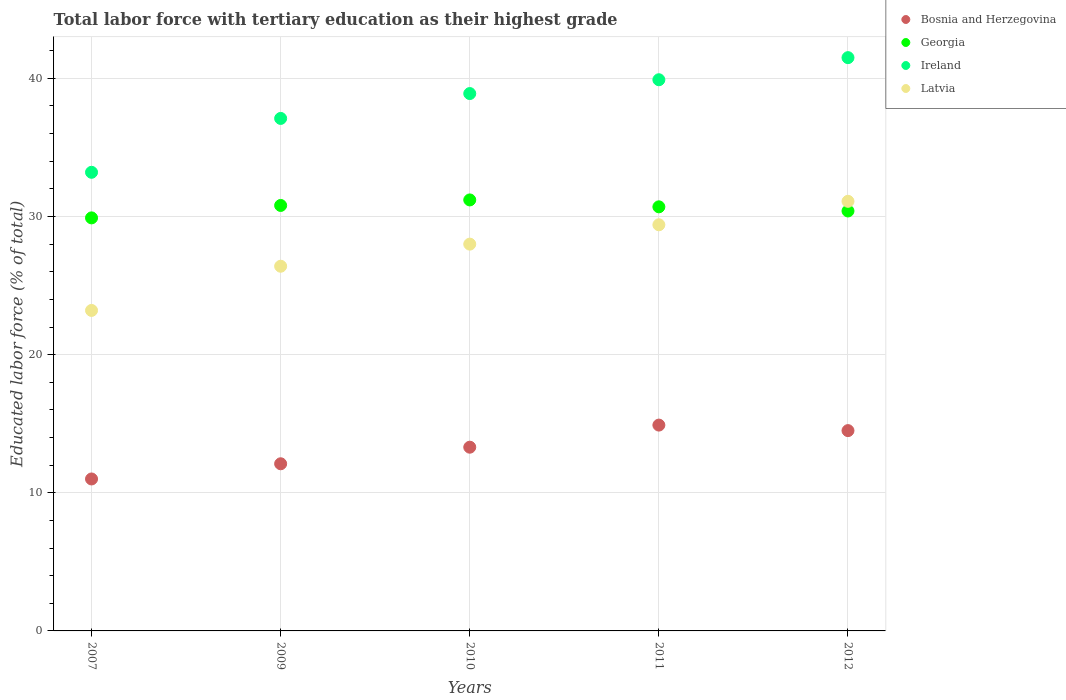How many different coloured dotlines are there?
Ensure brevity in your answer.  4. What is the percentage of male labor force with tertiary education in Ireland in 2011?
Your answer should be very brief. 39.9. Across all years, what is the maximum percentage of male labor force with tertiary education in Georgia?
Give a very brief answer. 31.2. In which year was the percentage of male labor force with tertiary education in Ireland maximum?
Provide a succinct answer. 2012. What is the total percentage of male labor force with tertiary education in Georgia in the graph?
Your answer should be compact. 153. What is the difference between the percentage of male labor force with tertiary education in Bosnia and Herzegovina in 2009 and that in 2010?
Ensure brevity in your answer.  -1.2. What is the difference between the percentage of male labor force with tertiary education in Bosnia and Herzegovina in 2011 and the percentage of male labor force with tertiary education in Georgia in 2010?
Provide a succinct answer. -16.3. What is the average percentage of male labor force with tertiary education in Ireland per year?
Your answer should be compact. 38.12. In the year 2009, what is the difference between the percentage of male labor force with tertiary education in Latvia and percentage of male labor force with tertiary education in Ireland?
Make the answer very short. -10.7. In how many years, is the percentage of male labor force with tertiary education in Ireland greater than 18 %?
Provide a short and direct response. 5. What is the ratio of the percentage of male labor force with tertiary education in Ireland in 2007 to that in 2009?
Provide a short and direct response. 0.89. Is the percentage of male labor force with tertiary education in Georgia in 2007 less than that in 2011?
Your answer should be very brief. Yes. What is the difference between the highest and the second highest percentage of male labor force with tertiary education in Latvia?
Offer a very short reply. 1.7. What is the difference between the highest and the lowest percentage of male labor force with tertiary education in Latvia?
Your answer should be compact. 7.9. In how many years, is the percentage of male labor force with tertiary education in Bosnia and Herzegovina greater than the average percentage of male labor force with tertiary education in Bosnia and Herzegovina taken over all years?
Offer a very short reply. 3. Is the sum of the percentage of male labor force with tertiary education in Latvia in 2009 and 2010 greater than the maximum percentage of male labor force with tertiary education in Bosnia and Herzegovina across all years?
Offer a very short reply. Yes. Is it the case that in every year, the sum of the percentage of male labor force with tertiary education in Ireland and percentage of male labor force with tertiary education in Latvia  is greater than the sum of percentage of male labor force with tertiary education in Georgia and percentage of male labor force with tertiary education in Bosnia and Herzegovina?
Provide a succinct answer. No. Is it the case that in every year, the sum of the percentage of male labor force with tertiary education in Ireland and percentage of male labor force with tertiary education in Latvia  is greater than the percentage of male labor force with tertiary education in Bosnia and Herzegovina?
Provide a succinct answer. Yes. How many years are there in the graph?
Your answer should be compact. 5. What is the difference between two consecutive major ticks on the Y-axis?
Offer a very short reply. 10. Are the values on the major ticks of Y-axis written in scientific E-notation?
Ensure brevity in your answer.  No. Does the graph contain grids?
Your answer should be compact. Yes. How many legend labels are there?
Your response must be concise. 4. How are the legend labels stacked?
Offer a terse response. Vertical. What is the title of the graph?
Provide a short and direct response. Total labor force with tertiary education as their highest grade. Does "St. Vincent and the Grenadines" appear as one of the legend labels in the graph?
Ensure brevity in your answer.  No. What is the label or title of the Y-axis?
Provide a short and direct response. Educated labor force (% of total). What is the Educated labor force (% of total) of Bosnia and Herzegovina in 2007?
Provide a succinct answer. 11. What is the Educated labor force (% of total) of Georgia in 2007?
Provide a succinct answer. 29.9. What is the Educated labor force (% of total) of Ireland in 2007?
Provide a succinct answer. 33.2. What is the Educated labor force (% of total) in Latvia in 2007?
Ensure brevity in your answer.  23.2. What is the Educated labor force (% of total) of Bosnia and Herzegovina in 2009?
Give a very brief answer. 12.1. What is the Educated labor force (% of total) of Georgia in 2009?
Offer a very short reply. 30.8. What is the Educated labor force (% of total) in Ireland in 2009?
Give a very brief answer. 37.1. What is the Educated labor force (% of total) of Latvia in 2009?
Ensure brevity in your answer.  26.4. What is the Educated labor force (% of total) of Bosnia and Herzegovina in 2010?
Offer a terse response. 13.3. What is the Educated labor force (% of total) of Georgia in 2010?
Provide a succinct answer. 31.2. What is the Educated labor force (% of total) in Ireland in 2010?
Provide a short and direct response. 38.9. What is the Educated labor force (% of total) of Bosnia and Herzegovina in 2011?
Give a very brief answer. 14.9. What is the Educated labor force (% of total) in Georgia in 2011?
Your answer should be compact. 30.7. What is the Educated labor force (% of total) of Ireland in 2011?
Ensure brevity in your answer.  39.9. What is the Educated labor force (% of total) in Latvia in 2011?
Provide a short and direct response. 29.4. What is the Educated labor force (% of total) of Bosnia and Herzegovina in 2012?
Offer a terse response. 14.5. What is the Educated labor force (% of total) in Georgia in 2012?
Make the answer very short. 30.4. What is the Educated labor force (% of total) of Ireland in 2012?
Provide a succinct answer. 41.5. What is the Educated labor force (% of total) of Latvia in 2012?
Your answer should be compact. 31.1. Across all years, what is the maximum Educated labor force (% of total) of Bosnia and Herzegovina?
Make the answer very short. 14.9. Across all years, what is the maximum Educated labor force (% of total) in Georgia?
Provide a succinct answer. 31.2. Across all years, what is the maximum Educated labor force (% of total) of Ireland?
Provide a short and direct response. 41.5. Across all years, what is the maximum Educated labor force (% of total) in Latvia?
Offer a terse response. 31.1. Across all years, what is the minimum Educated labor force (% of total) of Georgia?
Give a very brief answer. 29.9. Across all years, what is the minimum Educated labor force (% of total) of Ireland?
Your response must be concise. 33.2. Across all years, what is the minimum Educated labor force (% of total) in Latvia?
Provide a short and direct response. 23.2. What is the total Educated labor force (% of total) in Bosnia and Herzegovina in the graph?
Your answer should be very brief. 65.8. What is the total Educated labor force (% of total) of Georgia in the graph?
Keep it short and to the point. 153. What is the total Educated labor force (% of total) in Ireland in the graph?
Provide a succinct answer. 190.6. What is the total Educated labor force (% of total) in Latvia in the graph?
Ensure brevity in your answer.  138.1. What is the difference between the Educated labor force (% of total) in Bosnia and Herzegovina in 2007 and that in 2009?
Provide a succinct answer. -1.1. What is the difference between the Educated labor force (% of total) in Ireland in 2007 and that in 2009?
Offer a terse response. -3.9. What is the difference between the Educated labor force (% of total) of Latvia in 2007 and that in 2009?
Your response must be concise. -3.2. What is the difference between the Educated labor force (% of total) in Bosnia and Herzegovina in 2007 and that in 2010?
Your answer should be compact. -2.3. What is the difference between the Educated labor force (% of total) of Ireland in 2007 and that in 2010?
Provide a succinct answer. -5.7. What is the difference between the Educated labor force (% of total) in Latvia in 2007 and that in 2010?
Offer a terse response. -4.8. What is the difference between the Educated labor force (% of total) in Ireland in 2007 and that in 2011?
Offer a very short reply. -6.7. What is the difference between the Educated labor force (% of total) of Bosnia and Herzegovina in 2007 and that in 2012?
Your answer should be very brief. -3.5. What is the difference between the Educated labor force (% of total) in Georgia in 2007 and that in 2012?
Your response must be concise. -0.5. What is the difference between the Educated labor force (% of total) in Ireland in 2007 and that in 2012?
Offer a terse response. -8.3. What is the difference between the Educated labor force (% of total) in Latvia in 2007 and that in 2012?
Provide a short and direct response. -7.9. What is the difference between the Educated labor force (% of total) of Georgia in 2009 and that in 2010?
Provide a succinct answer. -0.4. What is the difference between the Educated labor force (% of total) in Georgia in 2009 and that in 2011?
Your answer should be compact. 0.1. What is the difference between the Educated labor force (% of total) of Bosnia and Herzegovina in 2009 and that in 2012?
Provide a short and direct response. -2.4. What is the difference between the Educated labor force (% of total) of Ireland in 2009 and that in 2012?
Your response must be concise. -4.4. What is the difference between the Educated labor force (% of total) of Latvia in 2009 and that in 2012?
Provide a short and direct response. -4.7. What is the difference between the Educated labor force (% of total) of Georgia in 2010 and that in 2011?
Provide a succinct answer. 0.5. What is the difference between the Educated labor force (% of total) of Ireland in 2010 and that in 2011?
Your answer should be compact. -1. What is the difference between the Educated labor force (% of total) of Bosnia and Herzegovina in 2010 and that in 2012?
Offer a very short reply. -1.2. What is the difference between the Educated labor force (% of total) of Latvia in 2010 and that in 2012?
Make the answer very short. -3.1. What is the difference between the Educated labor force (% of total) in Bosnia and Herzegovina in 2011 and that in 2012?
Provide a succinct answer. 0.4. What is the difference between the Educated labor force (% of total) of Ireland in 2011 and that in 2012?
Offer a very short reply. -1.6. What is the difference between the Educated labor force (% of total) of Bosnia and Herzegovina in 2007 and the Educated labor force (% of total) of Georgia in 2009?
Offer a terse response. -19.8. What is the difference between the Educated labor force (% of total) of Bosnia and Herzegovina in 2007 and the Educated labor force (% of total) of Ireland in 2009?
Offer a terse response. -26.1. What is the difference between the Educated labor force (% of total) in Bosnia and Herzegovina in 2007 and the Educated labor force (% of total) in Latvia in 2009?
Your response must be concise. -15.4. What is the difference between the Educated labor force (% of total) in Georgia in 2007 and the Educated labor force (% of total) in Ireland in 2009?
Your response must be concise. -7.2. What is the difference between the Educated labor force (% of total) of Georgia in 2007 and the Educated labor force (% of total) of Latvia in 2009?
Offer a very short reply. 3.5. What is the difference between the Educated labor force (% of total) of Ireland in 2007 and the Educated labor force (% of total) of Latvia in 2009?
Offer a terse response. 6.8. What is the difference between the Educated labor force (% of total) of Bosnia and Herzegovina in 2007 and the Educated labor force (% of total) of Georgia in 2010?
Provide a short and direct response. -20.2. What is the difference between the Educated labor force (% of total) of Bosnia and Herzegovina in 2007 and the Educated labor force (% of total) of Ireland in 2010?
Your response must be concise. -27.9. What is the difference between the Educated labor force (% of total) in Bosnia and Herzegovina in 2007 and the Educated labor force (% of total) in Latvia in 2010?
Your response must be concise. -17. What is the difference between the Educated labor force (% of total) of Ireland in 2007 and the Educated labor force (% of total) of Latvia in 2010?
Your response must be concise. 5.2. What is the difference between the Educated labor force (% of total) of Bosnia and Herzegovina in 2007 and the Educated labor force (% of total) of Georgia in 2011?
Ensure brevity in your answer.  -19.7. What is the difference between the Educated labor force (% of total) of Bosnia and Herzegovina in 2007 and the Educated labor force (% of total) of Ireland in 2011?
Ensure brevity in your answer.  -28.9. What is the difference between the Educated labor force (% of total) of Bosnia and Herzegovina in 2007 and the Educated labor force (% of total) of Latvia in 2011?
Your response must be concise. -18.4. What is the difference between the Educated labor force (% of total) of Georgia in 2007 and the Educated labor force (% of total) of Latvia in 2011?
Provide a succinct answer. 0.5. What is the difference between the Educated labor force (% of total) of Bosnia and Herzegovina in 2007 and the Educated labor force (% of total) of Georgia in 2012?
Ensure brevity in your answer.  -19.4. What is the difference between the Educated labor force (% of total) of Bosnia and Herzegovina in 2007 and the Educated labor force (% of total) of Ireland in 2012?
Offer a terse response. -30.5. What is the difference between the Educated labor force (% of total) of Bosnia and Herzegovina in 2007 and the Educated labor force (% of total) of Latvia in 2012?
Your answer should be very brief. -20.1. What is the difference between the Educated labor force (% of total) of Bosnia and Herzegovina in 2009 and the Educated labor force (% of total) of Georgia in 2010?
Offer a terse response. -19.1. What is the difference between the Educated labor force (% of total) of Bosnia and Herzegovina in 2009 and the Educated labor force (% of total) of Ireland in 2010?
Provide a succinct answer. -26.8. What is the difference between the Educated labor force (% of total) of Bosnia and Herzegovina in 2009 and the Educated labor force (% of total) of Latvia in 2010?
Provide a short and direct response. -15.9. What is the difference between the Educated labor force (% of total) in Bosnia and Herzegovina in 2009 and the Educated labor force (% of total) in Georgia in 2011?
Provide a succinct answer. -18.6. What is the difference between the Educated labor force (% of total) of Bosnia and Herzegovina in 2009 and the Educated labor force (% of total) of Ireland in 2011?
Your answer should be very brief. -27.8. What is the difference between the Educated labor force (% of total) of Bosnia and Herzegovina in 2009 and the Educated labor force (% of total) of Latvia in 2011?
Provide a short and direct response. -17.3. What is the difference between the Educated labor force (% of total) of Georgia in 2009 and the Educated labor force (% of total) of Latvia in 2011?
Offer a very short reply. 1.4. What is the difference between the Educated labor force (% of total) of Ireland in 2009 and the Educated labor force (% of total) of Latvia in 2011?
Ensure brevity in your answer.  7.7. What is the difference between the Educated labor force (% of total) in Bosnia and Herzegovina in 2009 and the Educated labor force (% of total) in Georgia in 2012?
Offer a terse response. -18.3. What is the difference between the Educated labor force (% of total) in Bosnia and Herzegovina in 2009 and the Educated labor force (% of total) in Ireland in 2012?
Provide a succinct answer. -29.4. What is the difference between the Educated labor force (% of total) of Bosnia and Herzegovina in 2009 and the Educated labor force (% of total) of Latvia in 2012?
Provide a short and direct response. -19. What is the difference between the Educated labor force (% of total) in Georgia in 2009 and the Educated labor force (% of total) in Ireland in 2012?
Offer a terse response. -10.7. What is the difference between the Educated labor force (% of total) of Georgia in 2009 and the Educated labor force (% of total) of Latvia in 2012?
Your response must be concise. -0.3. What is the difference between the Educated labor force (% of total) of Ireland in 2009 and the Educated labor force (% of total) of Latvia in 2012?
Provide a short and direct response. 6. What is the difference between the Educated labor force (% of total) of Bosnia and Herzegovina in 2010 and the Educated labor force (% of total) of Georgia in 2011?
Your response must be concise. -17.4. What is the difference between the Educated labor force (% of total) in Bosnia and Herzegovina in 2010 and the Educated labor force (% of total) in Ireland in 2011?
Ensure brevity in your answer.  -26.6. What is the difference between the Educated labor force (% of total) of Bosnia and Herzegovina in 2010 and the Educated labor force (% of total) of Latvia in 2011?
Offer a very short reply. -16.1. What is the difference between the Educated labor force (% of total) in Georgia in 2010 and the Educated labor force (% of total) in Ireland in 2011?
Your answer should be compact. -8.7. What is the difference between the Educated labor force (% of total) in Georgia in 2010 and the Educated labor force (% of total) in Latvia in 2011?
Provide a succinct answer. 1.8. What is the difference between the Educated labor force (% of total) of Ireland in 2010 and the Educated labor force (% of total) of Latvia in 2011?
Offer a terse response. 9.5. What is the difference between the Educated labor force (% of total) in Bosnia and Herzegovina in 2010 and the Educated labor force (% of total) in Georgia in 2012?
Offer a very short reply. -17.1. What is the difference between the Educated labor force (% of total) in Bosnia and Herzegovina in 2010 and the Educated labor force (% of total) in Ireland in 2012?
Keep it short and to the point. -28.2. What is the difference between the Educated labor force (% of total) of Bosnia and Herzegovina in 2010 and the Educated labor force (% of total) of Latvia in 2012?
Your response must be concise. -17.8. What is the difference between the Educated labor force (% of total) of Georgia in 2010 and the Educated labor force (% of total) of Latvia in 2012?
Provide a short and direct response. 0.1. What is the difference between the Educated labor force (% of total) in Ireland in 2010 and the Educated labor force (% of total) in Latvia in 2012?
Provide a succinct answer. 7.8. What is the difference between the Educated labor force (% of total) in Bosnia and Herzegovina in 2011 and the Educated labor force (% of total) in Georgia in 2012?
Your answer should be very brief. -15.5. What is the difference between the Educated labor force (% of total) of Bosnia and Herzegovina in 2011 and the Educated labor force (% of total) of Ireland in 2012?
Your answer should be very brief. -26.6. What is the difference between the Educated labor force (% of total) of Bosnia and Herzegovina in 2011 and the Educated labor force (% of total) of Latvia in 2012?
Your answer should be compact. -16.2. What is the difference between the Educated labor force (% of total) of Georgia in 2011 and the Educated labor force (% of total) of Ireland in 2012?
Make the answer very short. -10.8. What is the difference between the Educated labor force (% of total) of Ireland in 2011 and the Educated labor force (% of total) of Latvia in 2012?
Your answer should be compact. 8.8. What is the average Educated labor force (% of total) of Bosnia and Herzegovina per year?
Your answer should be very brief. 13.16. What is the average Educated labor force (% of total) of Georgia per year?
Ensure brevity in your answer.  30.6. What is the average Educated labor force (% of total) of Ireland per year?
Provide a short and direct response. 38.12. What is the average Educated labor force (% of total) of Latvia per year?
Offer a very short reply. 27.62. In the year 2007, what is the difference between the Educated labor force (% of total) in Bosnia and Herzegovina and Educated labor force (% of total) in Georgia?
Offer a very short reply. -18.9. In the year 2007, what is the difference between the Educated labor force (% of total) in Bosnia and Herzegovina and Educated labor force (% of total) in Ireland?
Offer a terse response. -22.2. In the year 2007, what is the difference between the Educated labor force (% of total) in Bosnia and Herzegovina and Educated labor force (% of total) in Latvia?
Provide a succinct answer. -12.2. In the year 2007, what is the difference between the Educated labor force (% of total) in Georgia and Educated labor force (% of total) in Ireland?
Your response must be concise. -3.3. In the year 2009, what is the difference between the Educated labor force (% of total) of Bosnia and Herzegovina and Educated labor force (% of total) of Georgia?
Offer a terse response. -18.7. In the year 2009, what is the difference between the Educated labor force (% of total) in Bosnia and Herzegovina and Educated labor force (% of total) in Latvia?
Ensure brevity in your answer.  -14.3. In the year 2009, what is the difference between the Educated labor force (% of total) of Georgia and Educated labor force (% of total) of Ireland?
Make the answer very short. -6.3. In the year 2010, what is the difference between the Educated labor force (% of total) of Bosnia and Herzegovina and Educated labor force (% of total) of Georgia?
Your answer should be very brief. -17.9. In the year 2010, what is the difference between the Educated labor force (% of total) in Bosnia and Herzegovina and Educated labor force (% of total) in Ireland?
Ensure brevity in your answer.  -25.6. In the year 2010, what is the difference between the Educated labor force (% of total) in Bosnia and Herzegovina and Educated labor force (% of total) in Latvia?
Keep it short and to the point. -14.7. In the year 2010, what is the difference between the Educated labor force (% of total) in Georgia and Educated labor force (% of total) in Ireland?
Ensure brevity in your answer.  -7.7. In the year 2010, what is the difference between the Educated labor force (% of total) in Georgia and Educated labor force (% of total) in Latvia?
Your answer should be very brief. 3.2. In the year 2010, what is the difference between the Educated labor force (% of total) in Ireland and Educated labor force (% of total) in Latvia?
Provide a short and direct response. 10.9. In the year 2011, what is the difference between the Educated labor force (% of total) in Bosnia and Herzegovina and Educated labor force (% of total) in Georgia?
Give a very brief answer. -15.8. In the year 2011, what is the difference between the Educated labor force (% of total) in Bosnia and Herzegovina and Educated labor force (% of total) in Ireland?
Your answer should be compact. -25. In the year 2011, what is the difference between the Educated labor force (% of total) in Georgia and Educated labor force (% of total) in Latvia?
Your answer should be compact. 1.3. In the year 2012, what is the difference between the Educated labor force (% of total) in Bosnia and Herzegovina and Educated labor force (% of total) in Georgia?
Give a very brief answer. -15.9. In the year 2012, what is the difference between the Educated labor force (% of total) in Bosnia and Herzegovina and Educated labor force (% of total) in Latvia?
Give a very brief answer. -16.6. In the year 2012, what is the difference between the Educated labor force (% of total) of Ireland and Educated labor force (% of total) of Latvia?
Keep it short and to the point. 10.4. What is the ratio of the Educated labor force (% of total) in Georgia in 2007 to that in 2009?
Your answer should be very brief. 0.97. What is the ratio of the Educated labor force (% of total) in Ireland in 2007 to that in 2009?
Your answer should be compact. 0.89. What is the ratio of the Educated labor force (% of total) of Latvia in 2007 to that in 2009?
Provide a succinct answer. 0.88. What is the ratio of the Educated labor force (% of total) in Bosnia and Herzegovina in 2007 to that in 2010?
Offer a very short reply. 0.83. What is the ratio of the Educated labor force (% of total) of Georgia in 2007 to that in 2010?
Make the answer very short. 0.96. What is the ratio of the Educated labor force (% of total) in Ireland in 2007 to that in 2010?
Your answer should be compact. 0.85. What is the ratio of the Educated labor force (% of total) in Latvia in 2007 to that in 2010?
Give a very brief answer. 0.83. What is the ratio of the Educated labor force (% of total) of Bosnia and Herzegovina in 2007 to that in 2011?
Keep it short and to the point. 0.74. What is the ratio of the Educated labor force (% of total) in Georgia in 2007 to that in 2011?
Make the answer very short. 0.97. What is the ratio of the Educated labor force (% of total) in Ireland in 2007 to that in 2011?
Ensure brevity in your answer.  0.83. What is the ratio of the Educated labor force (% of total) in Latvia in 2007 to that in 2011?
Keep it short and to the point. 0.79. What is the ratio of the Educated labor force (% of total) of Bosnia and Herzegovina in 2007 to that in 2012?
Offer a terse response. 0.76. What is the ratio of the Educated labor force (% of total) of Georgia in 2007 to that in 2012?
Your response must be concise. 0.98. What is the ratio of the Educated labor force (% of total) in Ireland in 2007 to that in 2012?
Your answer should be compact. 0.8. What is the ratio of the Educated labor force (% of total) of Latvia in 2007 to that in 2012?
Offer a very short reply. 0.75. What is the ratio of the Educated labor force (% of total) in Bosnia and Herzegovina in 2009 to that in 2010?
Make the answer very short. 0.91. What is the ratio of the Educated labor force (% of total) of Georgia in 2009 to that in 2010?
Give a very brief answer. 0.99. What is the ratio of the Educated labor force (% of total) in Ireland in 2009 to that in 2010?
Offer a terse response. 0.95. What is the ratio of the Educated labor force (% of total) of Latvia in 2009 to that in 2010?
Your answer should be very brief. 0.94. What is the ratio of the Educated labor force (% of total) in Bosnia and Herzegovina in 2009 to that in 2011?
Offer a very short reply. 0.81. What is the ratio of the Educated labor force (% of total) in Georgia in 2009 to that in 2011?
Offer a terse response. 1. What is the ratio of the Educated labor force (% of total) of Ireland in 2009 to that in 2011?
Offer a very short reply. 0.93. What is the ratio of the Educated labor force (% of total) of Latvia in 2009 to that in 2011?
Offer a very short reply. 0.9. What is the ratio of the Educated labor force (% of total) of Bosnia and Herzegovina in 2009 to that in 2012?
Keep it short and to the point. 0.83. What is the ratio of the Educated labor force (% of total) in Georgia in 2009 to that in 2012?
Ensure brevity in your answer.  1.01. What is the ratio of the Educated labor force (% of total) in Ireland in 2009 to that in 2012?
Offer a terse response. 0.89. What is the ratio of the Educated labor force (% of total) of Latvia in 2009 to that in 2012?
Your response must be concise. 0.85. What is the ratio of the Educated labor force (% of total) in Bosnia and Herzegovina in 2010 to that in 2011?
Your answer should be very brief. 0.89. What is the ratio of the Educated labor force (% of total) of Georgia in 2010 to that in 2011?
Provide a short and direct response. 1.02. What is the ratio of the Educated labor force (% of total) of Ireland in 2010 to that in 2011?
Keep it short and to the point. 0.97. What is the ratio of the Educated labor force (% of total) of Bosnia and Herzegovina in 2010 to that in 2012?
Ensure brevity in your answer.  0.92. What is the ratio of the Educated labor force (% of total) in Georgia in 2010 to that in 2012?
Give a very brief answer. 1.03. What is the ratio of the Educated labor force (% of total) in Ireland in 2010 to that in 2012?
Keep it short and to the point. 0.94. What is the ratio of the Educated labor force (% of total) of Latvia in 2010 to that in 2012?
Your response must be concise. 0.9. What is the ratio of the Educated labor force (% of total) in Bosnia and Herzegovina in 2011 to that in 2012?
Your answer should be very brief. 1.03. What is the ratio of the Educated labor force (% of total) of Georgia in 2011 to that in 2012?
Offer a terse response. 1.01. What is the ratio of the Educated labor force (% of total) in Ireland in 2011 to that in 2012?
Provide a short and direct response. 0.96. What is the ratio of the Educated labor force (% of total) in Latvia in 2011 to that in 2012?
Make the answer very short. 0.95. What is the difference between the highest and the second highest Educated labor force (% of total) in Bosnia and Herzegovina?
Provide a short and direct response. 0.4. What is the difference between the highest and the second highest Educated labor force (% of total) in Georgia?
Your answer should be very brief. 0.4. What is the difference between the highest and the second highest Educated labor force (% of total) in Latvia?
Your answer should be very brief. 1.7. What is the difference between the highest and the lowest Educated labor force (% of total) in Georgia?
Give a very brief answer. 1.3. What is the difference between the highest and the lowest Educated labor force (% of total) in Latvia?
Give a very brief answer. 7.9. 